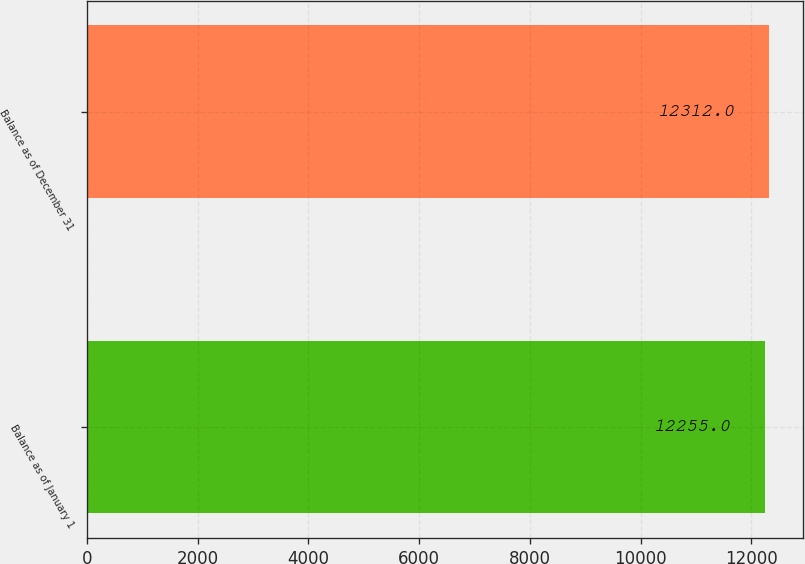Convert chart. <chart><loc_0><loc_0><loc_500><loc_500><bar_chart><fcel>Balance as of January 1<fcel>Balance as of December 31<nl><fcel>12255<fcel>12312<nl></chart> 